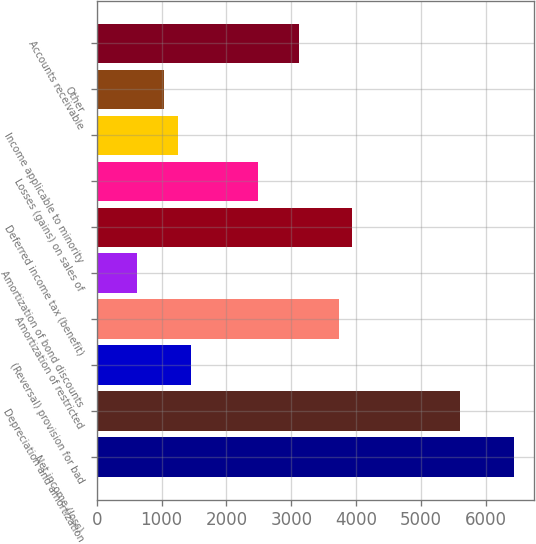Convert chart to OTSL. <chart><loc_0><loc_0><loc_500><loc_500><bar_chart><fcel>Net income (loss)<fcel>Depreciation and amortization<fcel>(Reversal) provision for bad<fcel>Amortization of restricted<fcel>Amortization of bond discounts<fcel>Deferred income tax (benefit)<fcel>Losses (gains) on sales of<fcel>Income applicable to minority<fcel>Other<fcel>Accounts receivable<nl><fcel>6429.41<fcel>5600.17<fcel>1453.97<fcel>3734.38<fcel>624.73<fcel>3941.69<fcel>2490.52<fcel>1246.66<fcel>1039.35<fcel>3112.45<nl></chart> 